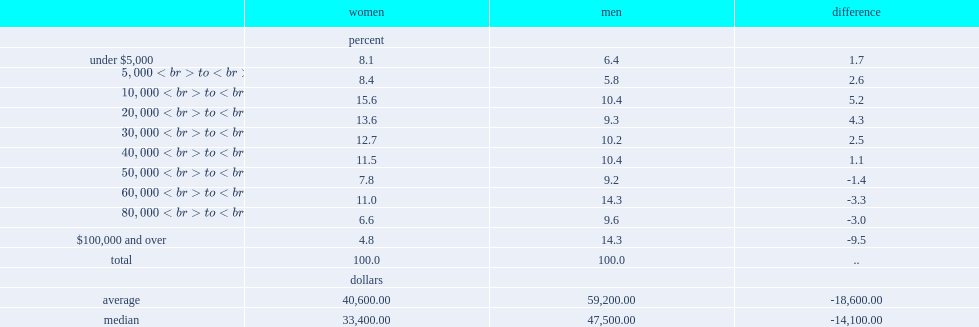Which gender had a lower average annual earnings from wages, salaries and commissions in 2017, women or men? Women. 